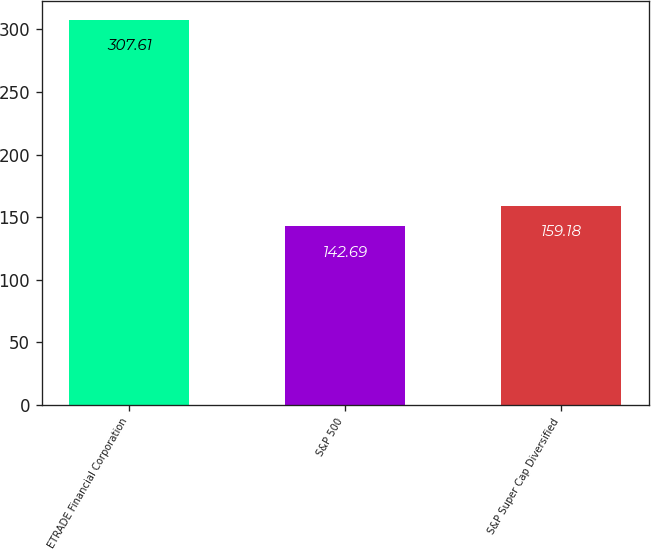Convert chart. <chart><loc_0><loc_0><loc_500><loc_500><bar_chart><fcel>ETRADE Financial Corporation<fcel>S&P 500<fcel>S&P Super Cap Diversified<nl><fcel>307.61<fcel>142.69<fcel>159.18<nl></chart> 